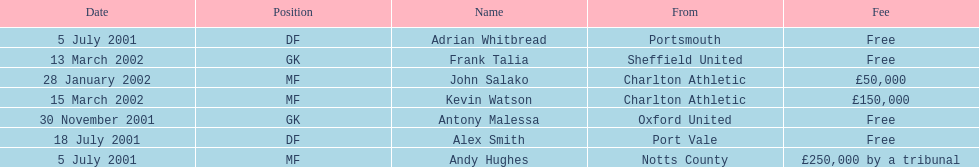Who shifted before 1 august 2001? Andy Hughes, Adrian Whitbread, Alex Smith. 